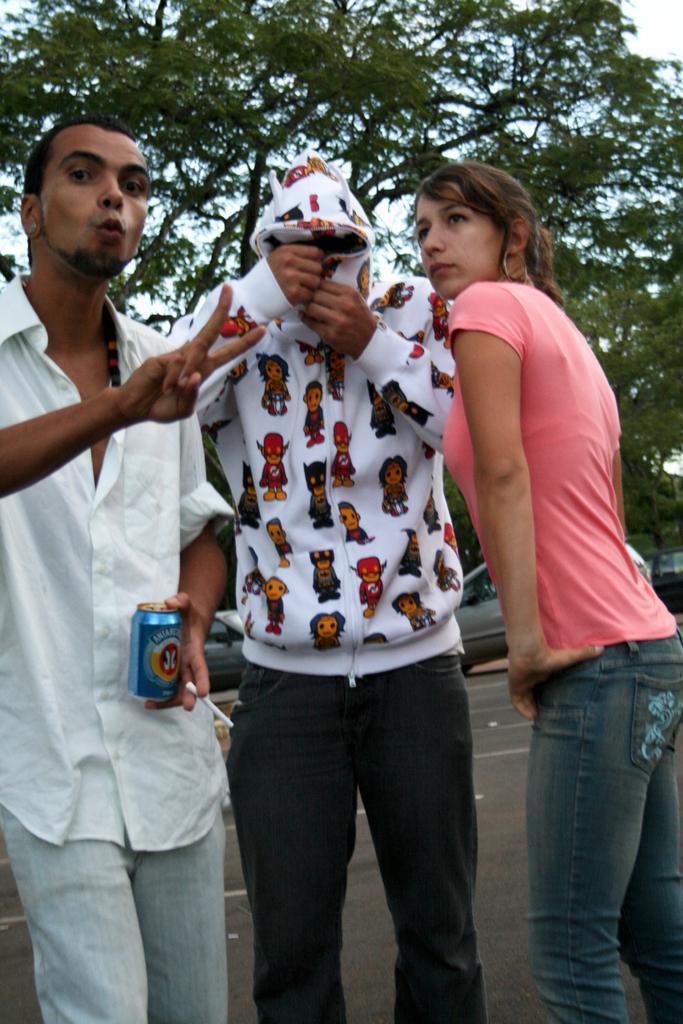In one or two sentences, can you explain what this image depicts? In this image we can see three people standing. The man standing on the left is holding a tin. In the background there are cars, trees and sky. 